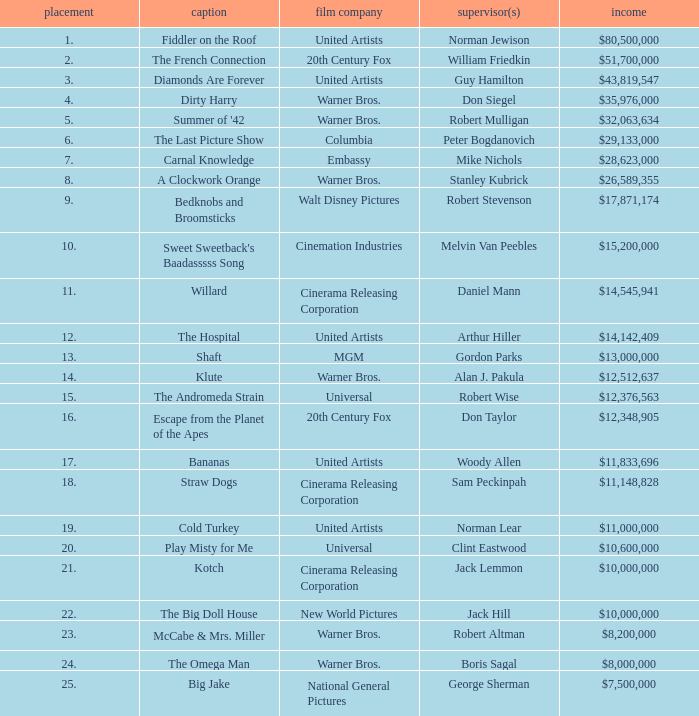Which title with a ranking below 19 has a gross revenue of $11,833,696? Bananas. 